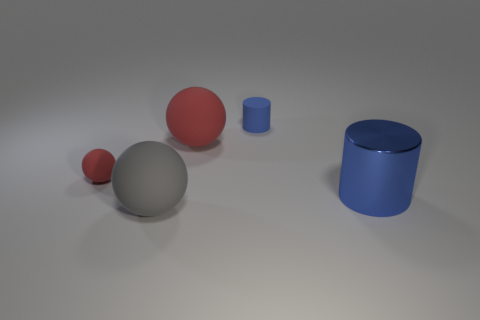Subtract all red balls. How many balls are left? 1 Add 2 tiny matte balls. How many objects exist? 7 Subtract all balls. How many objects are left? 2 Subtract all gray balls. How many balls are left? 2 Subtract 2 spheres. How many spheres are left? 1 Subtract all brown cylinders. Subtract all yellow spheres. How many cylinders are left? 2 Subtract all purple blocks. How many red balls are left? 2 Subtract all big blue metal objects. Subtract all red spheres. How many objects are left? 2 Add 3 gray rubber spheres. How many gray rubber spheres are left? 4 Add 4 small blue rubber objects. How many small blue rubber objects exist? 5 